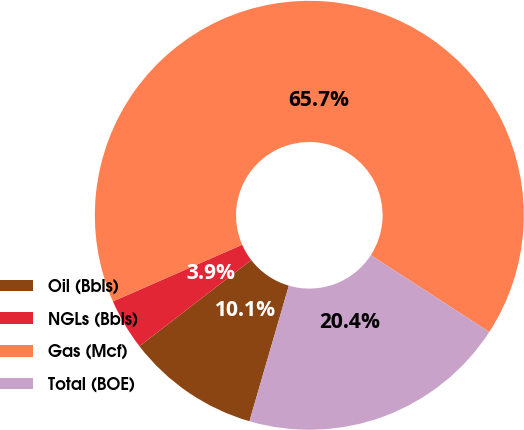Convert chart to OTSL. <chart><loc_0><loc_0><loc_500><loc_500><pie_chart><fcel>Oil (Bbls)<fcel>NGLs (Bbls)<fcel>Gas (Mcf)<fcel>Total (BOE)<nl><fcel>10.05%<fcel>3.87%<fcel>65.72%<fcel>20.35%<nl></chart> 